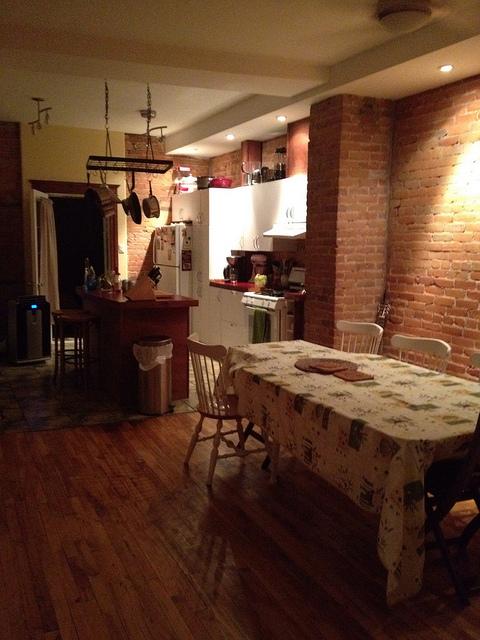Where are the pots?
Short answer required. Hanging. What type of oven is in the kitchen?
Short answer required. Electric. What is hanging from the ceiling?
Quick response, please. Lights. Is this a baggage claim?
Concise answer only. No. Is the brick wall on the right painted?
Keep it brief. No. Is this in a home?
Be succinct. Yes. 